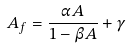Convert formula to latex. <formula><loc_0><loc_0><loc_500><loc_500>A _ { f } = \frac { \alpha A } { 1 - \beta A } + \gamma</formula> 